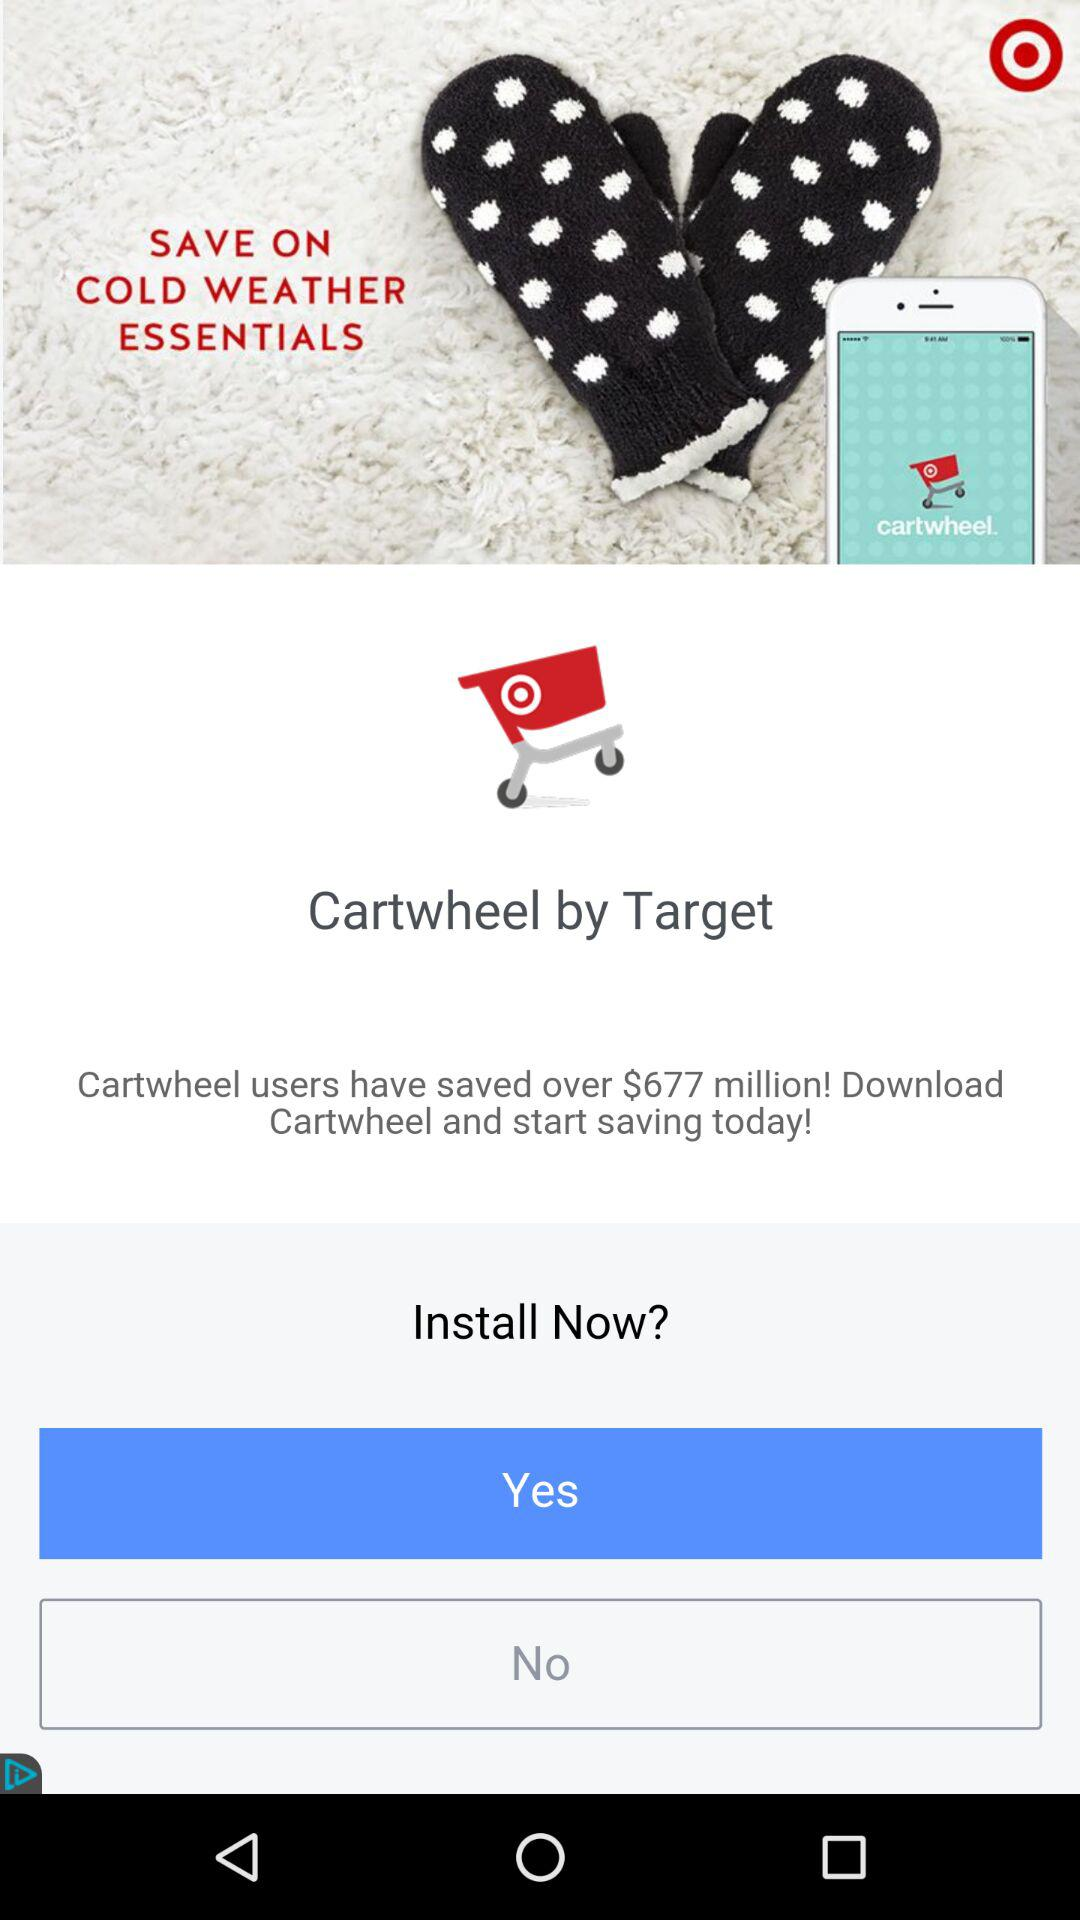How much money have Cartwheel users saved in total?
Answer the question using a single word or phrase. $677 million 